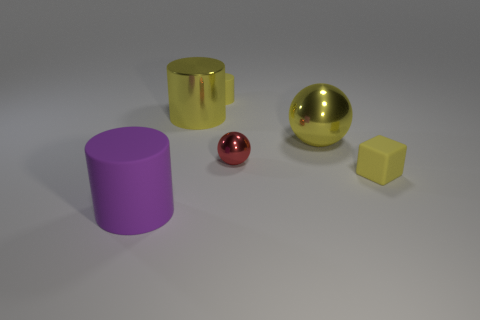What is the material of the yellow thing that is the same size as the yellow rubber cylinder?
Provide a succinct answer. Rubber. How many other objects are there of the same material as the yellow sphere?
Make the answer very short. 2. Is the number of big rubber objects that are left of the purple cylinder less than the number of small shiny objects?
Keep it short and to the point. Yes. Is the shape of the red object the same as the large purple object?
Provide a short and direct response. No. There is a yellow metal thing that is to the right of the big cylinder that is right of the big purple thing in front of the small cylinder; how big is it?
Offer a very short reply. Large. There is a big yellow object that is the same shape as the small red metallic object; what material is it?
Offer a terse response. Metal. Is there anything else that is the same size as the purple cylinder?
Your response must be concise. Yes. There is a object that is behind the big cylinder that is behind the purple object; what size is it?
Your answer should be very brief. Small. What is the color of the big rubber thing?
Give a very brief answer. Purple. How many big yellow shiny objects are on the right side of the ball behind the small red metal thing?
Offer a very short reply. 0. 